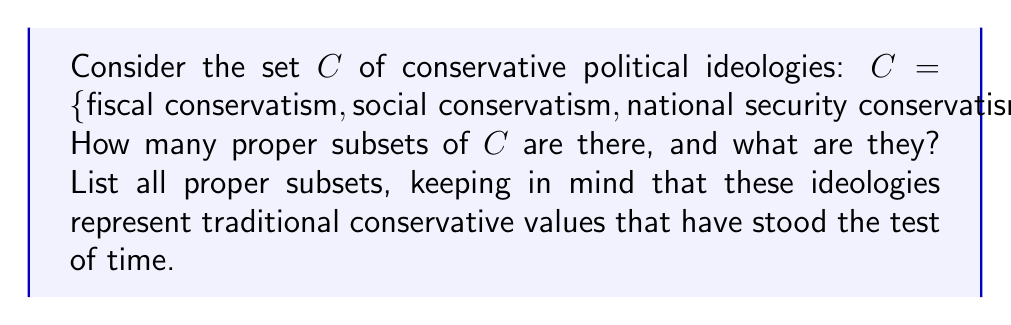Solve this math problem. To solve this problem, let's approach it step-by-step:

1) First, recall that a proper subset is any subset of a set that is not equal to the set itself and is not empty.

2) For a set with $n$ elements, the total number of subsets is $2^n$. This includes the empty set and the set itself.

3) In this case, $|C| = 3$, so the total number of subsets is $2^3 = 8$.

4) To find the number of proper subsets, we subtract 2 from this total (for the empty set and the set itself):
   $8 - 2 = 6$ proper subsets

5) Now, let's list all these proper subsets:
   - Subsets with 1 element:
     $\{\text{fiscal conservatism}\}$
     $\{\text{social conservatism}\}$
     $\{\text{national security conservatism}\}$
   
   - Subsets with 2 elements:
     $\{\text{fiscal conservatism}, \text{social conservatism}\}$
     $\{\text{fiscal conservatism}, \text{national security conservatism}\}$
     $\{\text{social conservatism}, \text{national security conservatism}\}$

These 6 subsets represent various combinations of conservative ideologies, each upholding important traditional values in different aspects of governance and society.
Answer: There are 6 proper subsets of $C$:
$\{\text{fiscal conservatism}\}$
$\{\text{social conservatism}\}$
$\{\text{national security conservatism}\}$
$\{\text{fiscal conservatism}, \text{social conservatism}\}$
$\{\text{fiscal conservatism}, \text{national security conservatism}\}$
$\{\text{social conservatism}, \text{national security conservatism}\}$ 